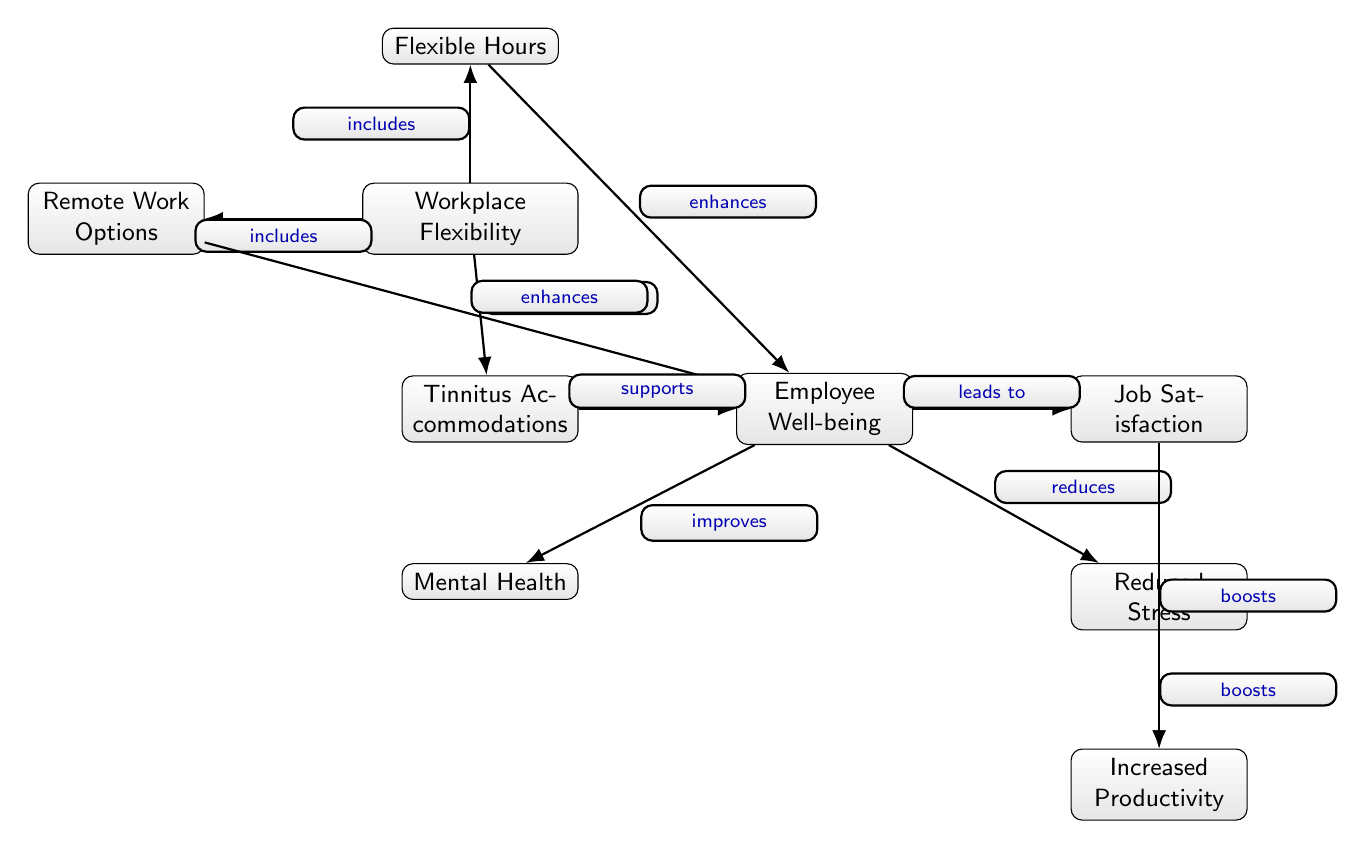What node represents flexible work options? The diagram includes a node labeled "Remote Work Options" that clearly indicates the concept of flexible work options available in the workplace.
Answer: Remote Work Options How many edges are there in the diagram? By counting, there are ten distinct connections (edges) between the nodes that represent relationships and influences among them.
Answer: 10 What does "Workplace Flexibility" lead to? The diagram shows an arrow leading from "Workplace Flexibility" to "Employee Well-being," indicating that flexibility contributes to overall well-being.
Answer: Employee Well-being Which node supports employee well-being? The node labeled "Tinnitus Accommodations" directly connects to "Employee Well-being", showing that it supports the well-being of employees.
Answer: Tinnitus Accommodations What is enhanced by flexible hours? The relationship diagram indicates that flexible hours have a direct enhancement effect on "Employee Well-being," implying that they positively influence well-being.
Answer: Employee Well-being What boosts increased productivity? Both "Reduced Stress" and "Job Satisfaction" are nodes that lead to "Increased Productivity," indicating that they are contributors to boosting productivity levels.
Answer: Reduced Stress; Job Satisfaction How many nodes are there related to employee well-being? There are four nodes directly linked to "Employee Well-being," including "Job Satisfaction," "Mental Health," "Tinnitus Accommodations," and "Reduced Stress."
Answer: 4 How does remote work impact employee well-being? The diagram illustrates that remote work options enhance employee well-being, suggesting that flexibility in remote work directly contributes to a better well-being environment.
Answer: enhances What type of diagram is this? The characteristics of the diagram featuring nodes representing concepts and arrows denoting relationships indicate it is a social science diagram, focusing on workplace flexibility and well-being.
Answer: Social Science Diagram 